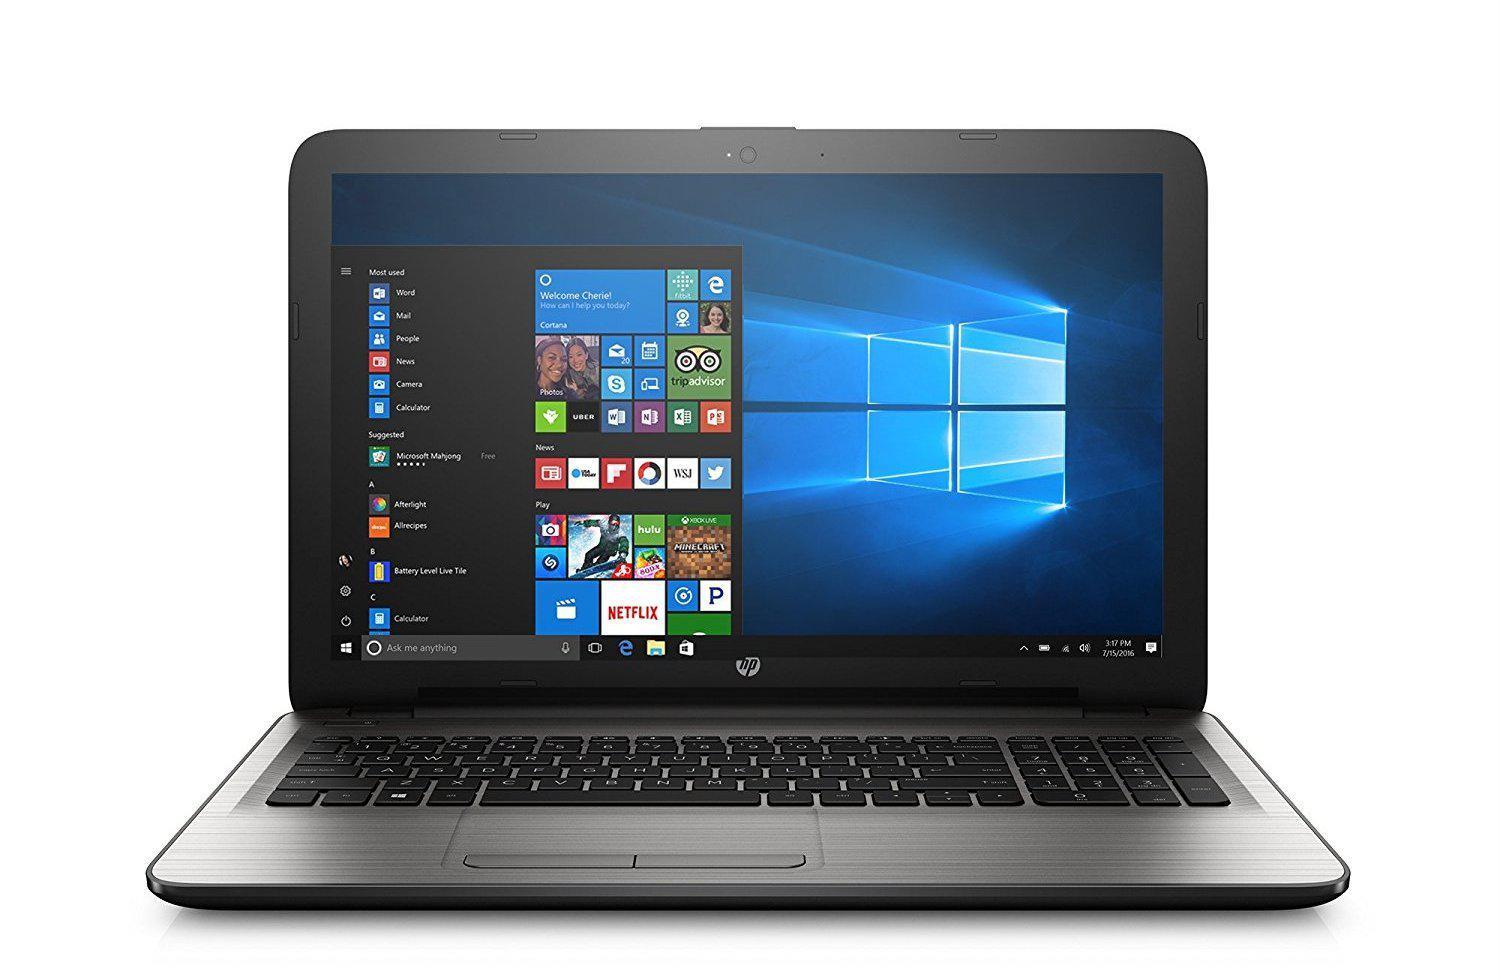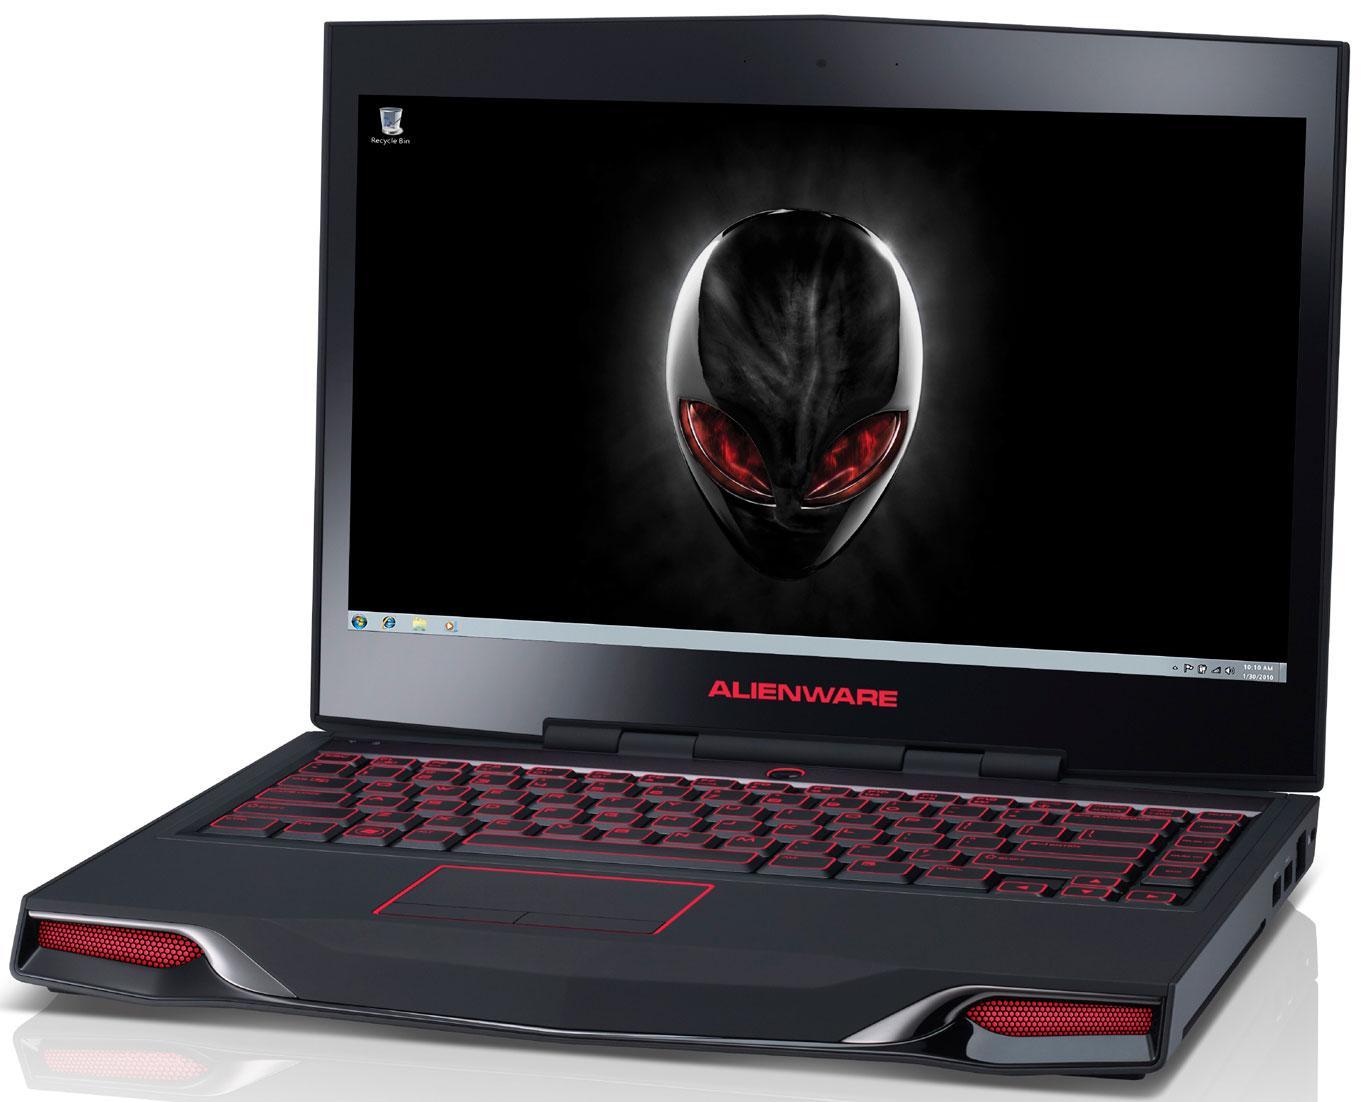The first image is the image on the left, the second image is the image on the right. Evaluate the accuracy of this statement regarding the images: "An image includes a laptop that is facing directly forward.". Is it true? Answer yes or no. Yes. The first image is the image on the left, the second image is the image on the right. Assess this claim about the two images: "A mouse is connected to the computer on the right.". Correct or not? Answer yes or no. No. 